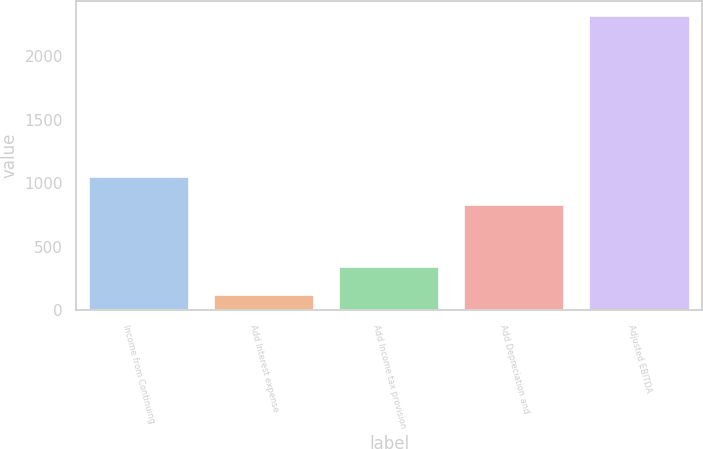<chart> <loc_0><loc_0><loc_500><loc_500><bar_chart><fcel>Income from Continuing<fcel>Add Interest expense<fcel>Add Income tax provision<fcel>Add Depreciation and<fcel>Adjusted EBITDA<nl><fcel>1046.35<fcel>121.9<fcel>341.45<fcel>826.8<fcel>2317.4<nl></chart> 